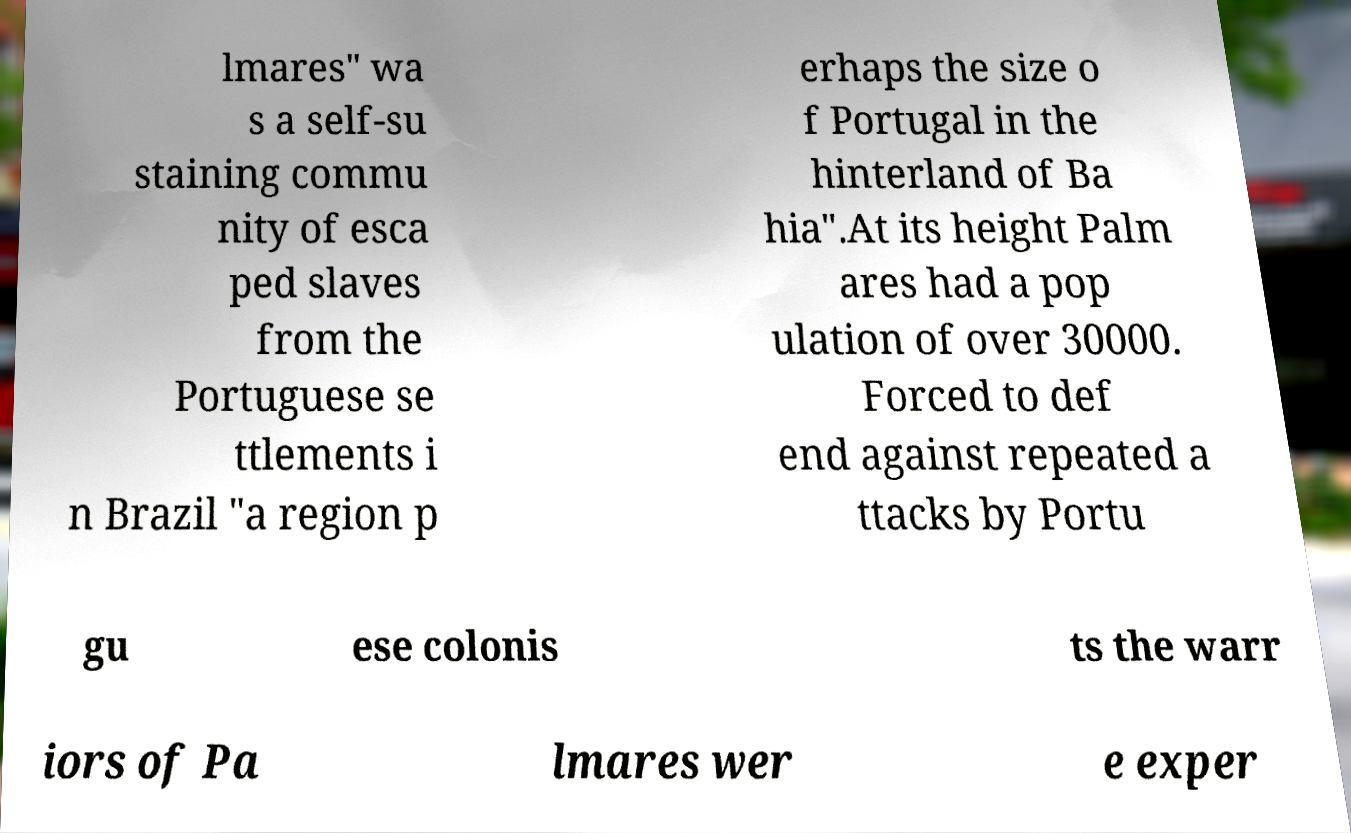Please identify and transcribe the text found in this image. lmares" wa s a self-su staining commu nity of esca ped slaves from the Portuguese se ttlements i n Brazil "a region p erhaps the size o f Portugal in the hinterland of Ba hia".At its height Palm ares had a pop ulation of over 30000. Forced to def end against repeated a ttacks by Portu gu ese colonis ts the warr iors of Pa lmares wer e exper 